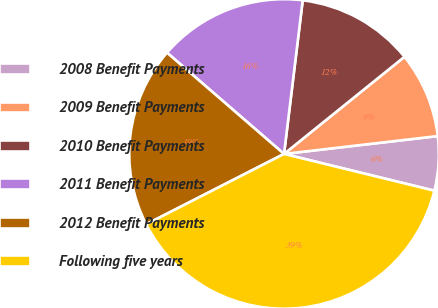Convert chart. <chart><loc_0><loc_0><loc_500><loc_500><pie_chart><fcel>2008 Benefit Payments<fcel>2009 Benefit Payments<fcel>2010 Benefit Payments<fcel>2011 Benefit Payments<fcel>2012 Benefit Payments<fcel>Following five years<nl><fcel>5.66%<fcel>8.96%<fcel>12.27%<fcel>15.57%<fcel>18.87%<fcel>38.67%<nl></chart> 